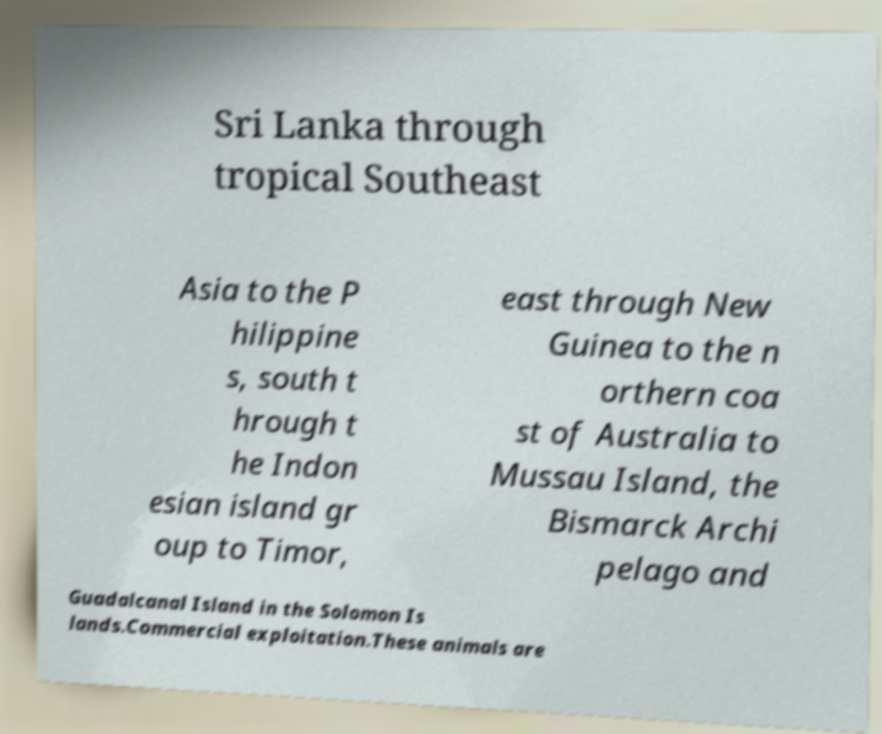Could you extract and type out the text from this image? Sri Lanka through tropical Southeast Asia to the P hilippine s, south t hrough t he Indon esian island gr oup to Timor, east through New Guinea to the n orthern coa st of Australia to Mussau Island, the Bismarck Archi pelago and Guadalcanal Island in the Solomon Is lands.Commercial exploitation.These animals are 